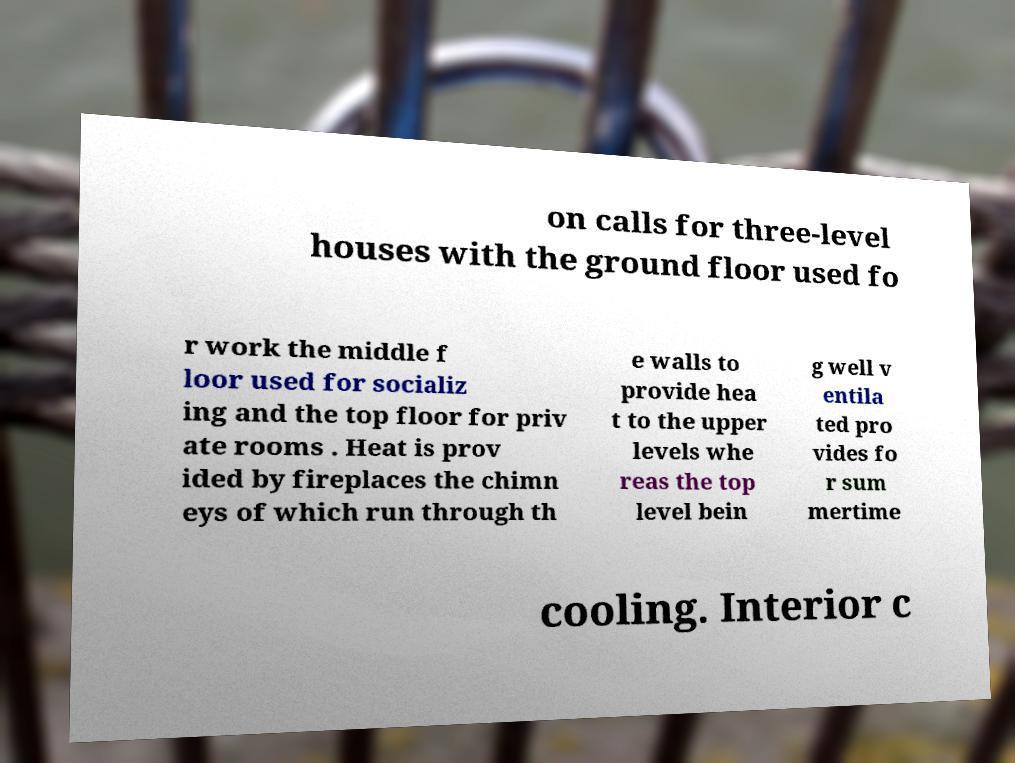What messages or text are displayed in this image? I need them in a readable, typed format. on calls for three-level houses with the ground floor used fo r work the middle f loor used for socializ ing and the top floor for priv ate rooms . Heat is prov ided by fireplaces the chimn eys of which run through th e walls to provide hea t to the upper levels whe reas the top level bein g well v entila ted pro vides fo r sum mertime cooling. Interior c 